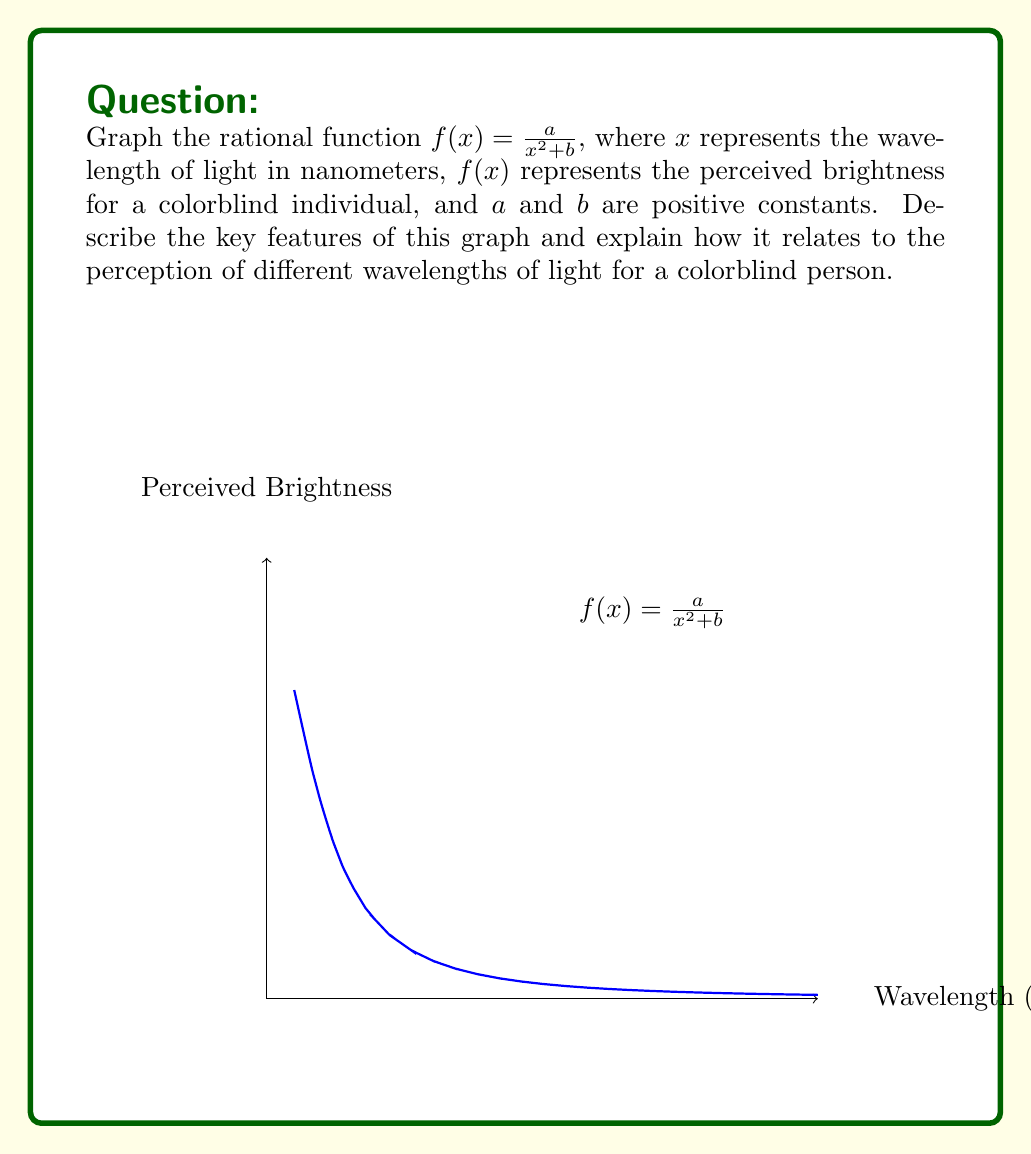Help me with this question. To graph and analyze this rational function, we'll follow these steps:

1) Domain: The domain is all real numbers except where the denominator equals zero. Since $x^2 + b$ is always positive (as $b$ is positive), the domain is all real numbers: $(-\infty, \infty)$.

2) Y-intercept: When $x = 0$, $f(0) = \frac{a}{b}$.

3) X-intercepts: There are no x-intercepts as the numerator is always positive.

4) Vertical asymptote: None, as the denominator is never zero.

5) Horizontal asymptote: As $x \to \pm\infty$, $f(x) \to 0$. The x-axis is the horizontal asymptote.

6) Shape: This is an even function, symmetric about the y-axis. It has a maximum at $x = 0$ and decreases on both sides, approaching but never touching the x-axis.

For a colorblind individual:
- The peak at $x = 0$ represents the wavelength of maximum sensitivity.
- The symmetric nature shows equal sensitivity to wavelengths equidistant from the peak.
- The gradual decrease on both sides indicates reduced sensitivity to wavelengths further from the peak.
- The lack of additional peaks or troughs suggests a simplified color perception compared to typical trichromatic vision.

This graph effectively models the reduced color discrimination in colorblindness, where multiple wavelengths may be perceived with similar brightness, leading to difficulty distinguishing certain colors.
Answer: Bell-shaped curve centered at origin, approaching x-axis as $|x| \to \infty$ 